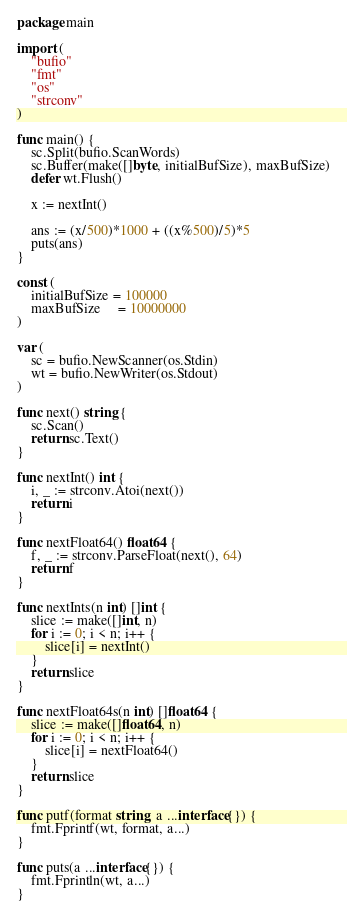<code> <loc_0><loc_0><loc_500><loc_500><_Go_>package main

import (
	"bufio"
	"fmt"
	"os"
	"strconv"
)

func main() {
	sc.Split(bufio.ScanWords)
	sc.Buffer(make([]byte, initialBufSize), maxBufSize)
	defer wt.Flush()

	x := nextInt()

	ans := (x/500)*1000 + ((x%500)/5)*5
	puts(ans)
}

const (
	initialBufSize = 100000
	maxBufSize     = 10000000
)

var (
	sc = bufio.NewScanner(os.Stdin)
	wt = bufio.NewWriter(os.Stdout)
)

func next() string {
	sc.Scan()
	return sc.Text()
}

func nextInt() int {
	i, _ := strconv.Atoi(next())
	return i
}

func nextFloat64() float64 {
	f, _ := strconv.ParseFloat(next(), 64)
	return f
}

func nextInts(n int) []int {
	slice := make([]int, n)
	for i := 0; i < n; i++ {
		slice[i] = nextInt()
	}
	return slice
}

func nextFloat64s(n int) []float64 {
	slice := make([]float64, n)
	for i := 0; i < n; i++ {
		slice[i] = nextFloat64()
	}
	return slice
}

func putf(format string, a ...interface{}) {
	fmt.Fprintf(wt, format, a...)
}

func puts(a ...interface{}) {
	fmt.Fprintln(wt, a...)
}
</code> 